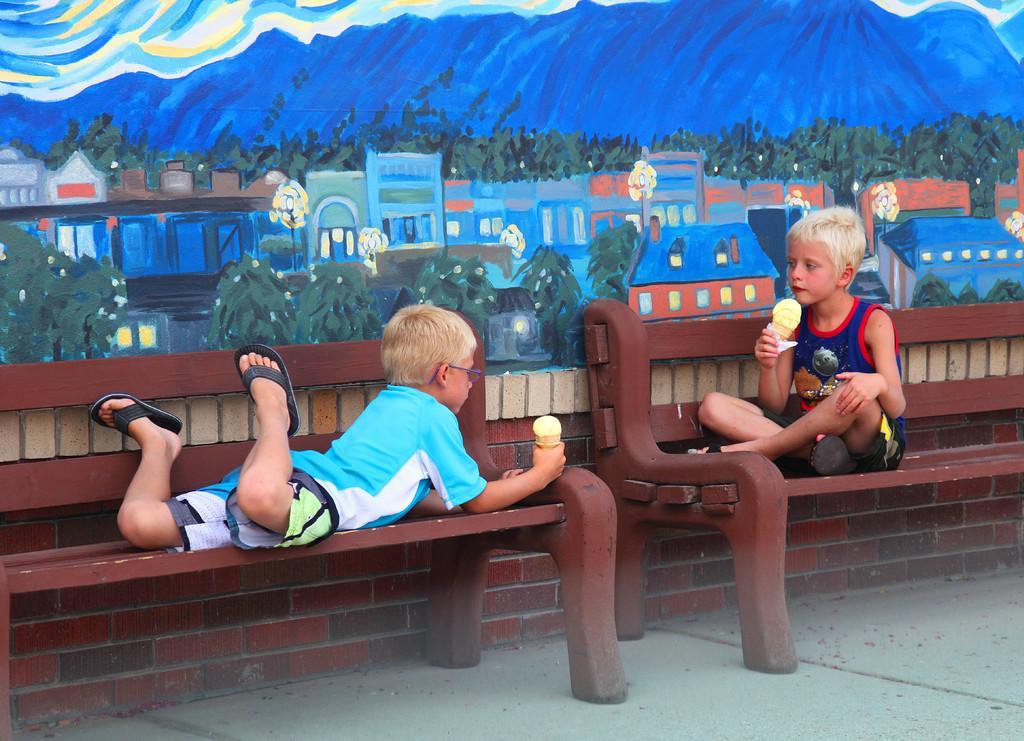Could you give a brief overview of what you see in this image? In the picture I can see two kids are holding ice creams in hands. The child on the left side is lying on a wooden bench and the child on the right side is sitting on a wooden bench. In the background I can see a wall which has painting of buildings, trees and some other things. 